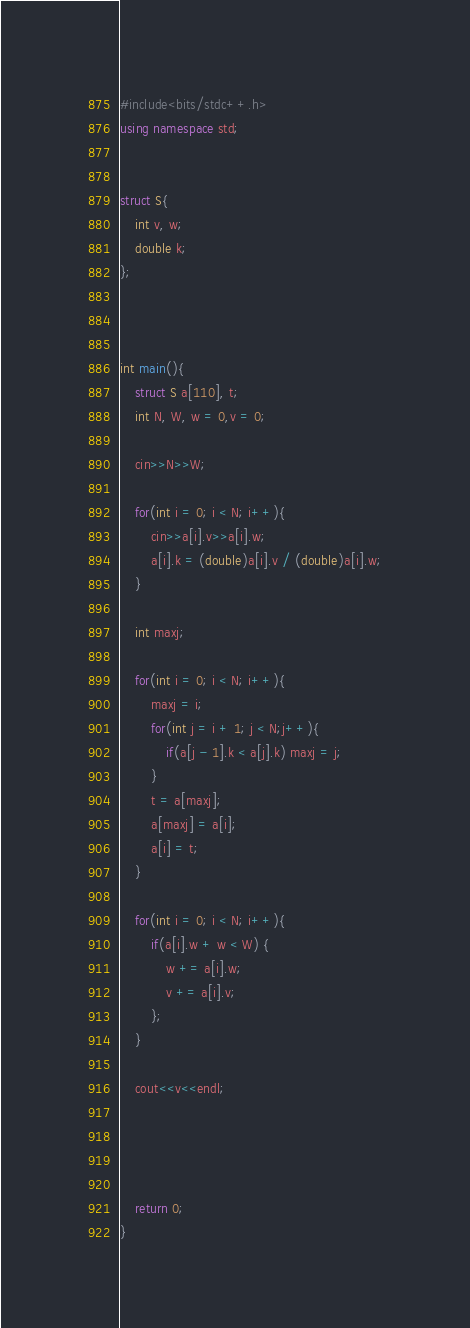<code> <loc_0><loc_0><loc_500><loc_500><_C++_>#include<bits/stdc++.h>
using namespace std;


struct S{
	int v, w;
	double k;
};



int main(){
	struct S a[110], t;
	int N, W, w = 0,v = 0;
	
	cin>>N>>W;

	for(int i = 0; i < N; i++){
		cin>>a[i].v>>a[i].w;
		a[i].k = (double)a[i].v / (double)a[i].w;
	}
	
	int maxj;
	
	for(int i = 0; i < N; i++){
		maxj = i;
		for(int j = i + 1; j < N;j++){
			if(a[j - 1].k < a[j].k) maxj = j;
		}
		t = a[maxj];
		a[maxj] = a[i];
		a[i] = t;
	}
	
	for(int i = 0; i < N; i++){
		if(a[i].w + w < W) {
			w += a[i].w;
			v += a[i].v;
		};
	}

	cout<<v<<endl;
	
	
	
	
	return 0;
}

</code> 